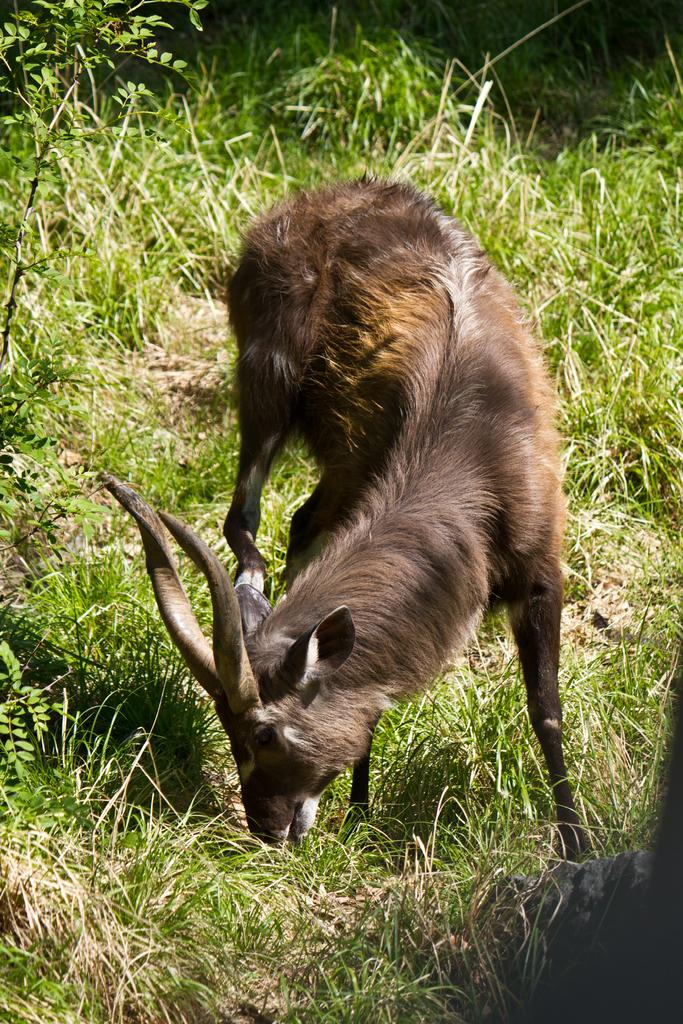What type of animal can be seen in the image? There is an animal with horns in the image. What is the animal doing in the image? The animal is eating grass. What type of vegetation is present on the ground in the image? There is grass on the ground in the image. Is the animal coughing while eating the grass in the image? There is no indication in the image that the animal is coughing while eating the grass. 